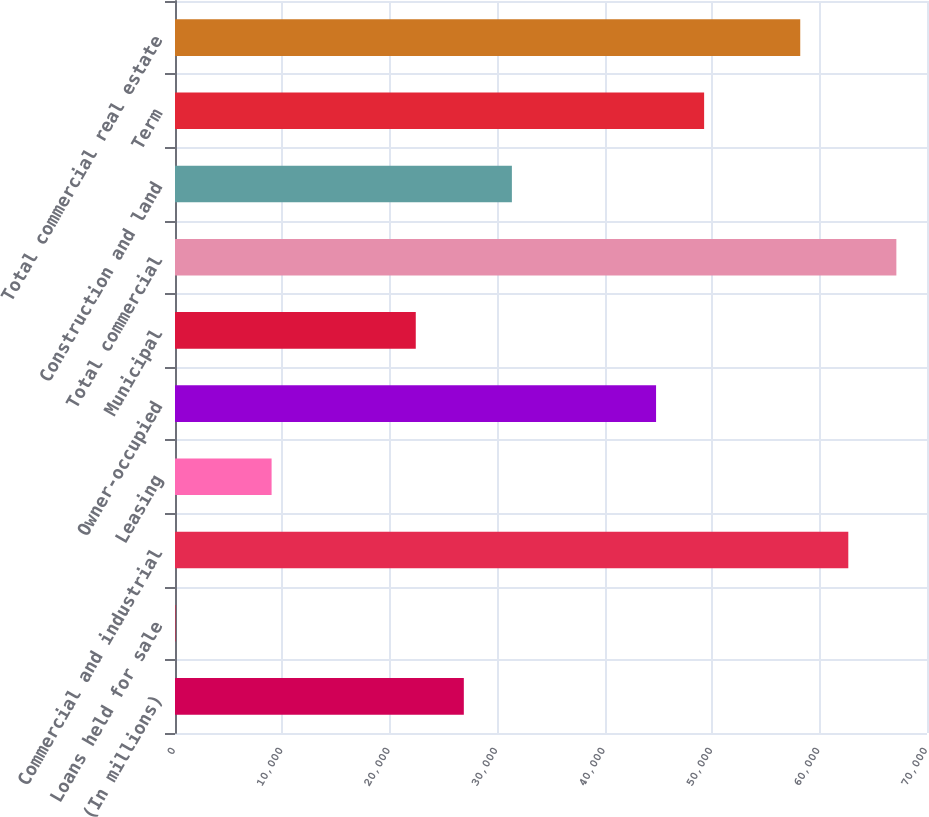Convert chart. <chart><loc_0><loc_0><loc_500><loc_500><bar_chart><fcel>(In millions)<fcel>Loans held for sale<fcel>Commercial and industrial<fcel>Leasing<fcel>Owner-occupied<fcel>Municipal<fcel>Total commercial<fcel>Construction and land<fcel>Term<fcel>Total commercial real estate<nl><fcel>26885.6<fcel>44<fcel>62674.4<fcel>8991.2<fcel>44780<fcel>22412<fcel>67148<fcel>31359.2<fcel>49253.6<fcel>58200.8<nl></chart> 